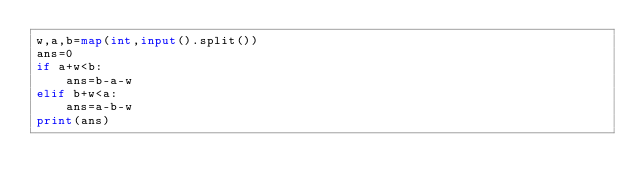Convert code to text. <code><loc_0><loc_0><loc_500><loc_500><_Python_>w,a,b=map(int,input().split())
ans=0
if a+w<b:
    ans=b-a-w
elif b+w<a:
    ans=a-b-w
print(ans)</code> 